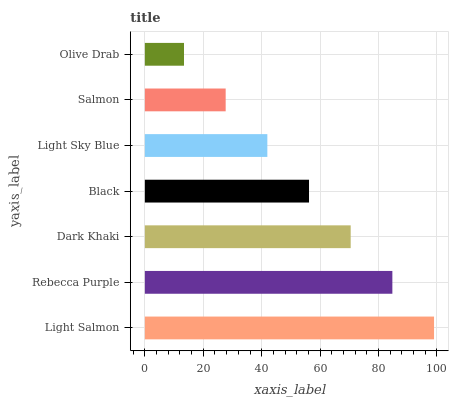Is Olive Drab the minimum?
Answer yes or no. Yes. Is Light Salmon the maximum?
Answer yes or no. Yes. Is Rebecca Purple the minimum?
Answer yes or no. No. Is Rebecca Purple the maximum?
Answer yes or no. No. Is Light Salmon greater than Rebecca Purple?
Answer yes or no. Yes. Is Rebecca Purple less than Light Salmon?
Answer yes or no. Yes. Is Rebecca Purple greater than Light Salmon?
Answer yes or no. No. Is Light Salmon less than Rebecca Purple?
Answer yes or no. No. Is Black the high median?
Answer yes or no. Yes. Is Black the low median?
Answer yes or no. Yes. Is Rebecca Purple the high median?
Answer yes or no. No. Is Light Sky Blue the low median?
Answer yes or no. No. 